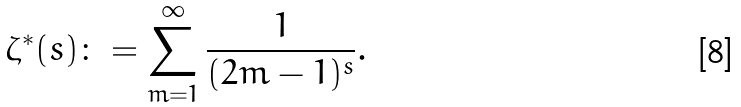Convert formula to latex. <formula><loc_0><loc_0><loc_500><loc_500>\zeta ^ { \ast } ( s ) \colon = \sum _ { m = 1 } ^ { \infty } \frac { 1 } { ( 2 m - 1 ) ^ { s } } .</formula> 